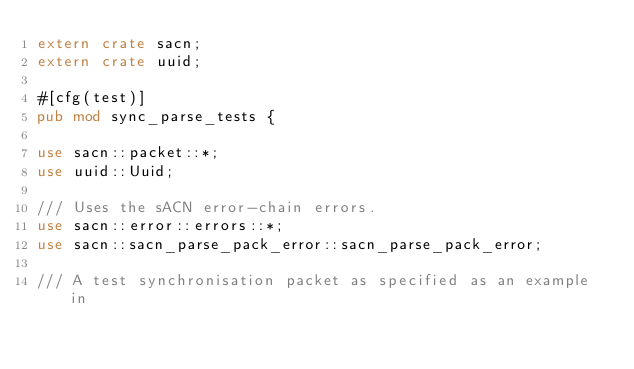<code> <loc_0><loc_0><loc_500><loc_500><_Rust_>extern crate sacn;
extern crate uuid;

#[cfg(test)]
pub mod sync_parse_tests {

use sacn::packet::*;
use uuid::Uuid;

/// Uses the sACN error-chain errors.
use sacn::error::errors::*;
use sacn::sacn_parse_pack_error::sacn_parse_pack_error;

/// A test synchronisation packet as specified as an example in</code> 